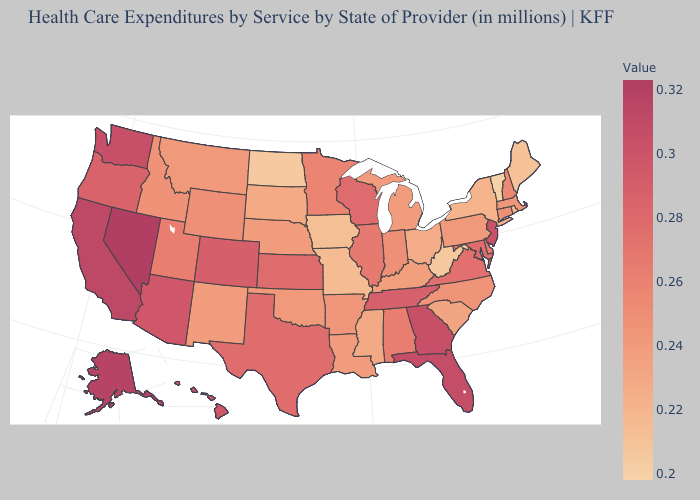Does the map have missing data?
Short answer required. No. Which states have the lowest value in the South?
Be succinct. West Virginia. Is the legend a continuous bar?
Write a very short answer. Yes. Does Maryland have a higher value than Alaska?
Concise answer only. No. Does New Mexico have a higher value than West Virginia?
Quick response, please. Yes. Among the states that border South Dakota , which have the lowest value?
Keep it brief. North Dakota. Which states have the lowest value in the Northeast?
Quick response, please. Vermont. 